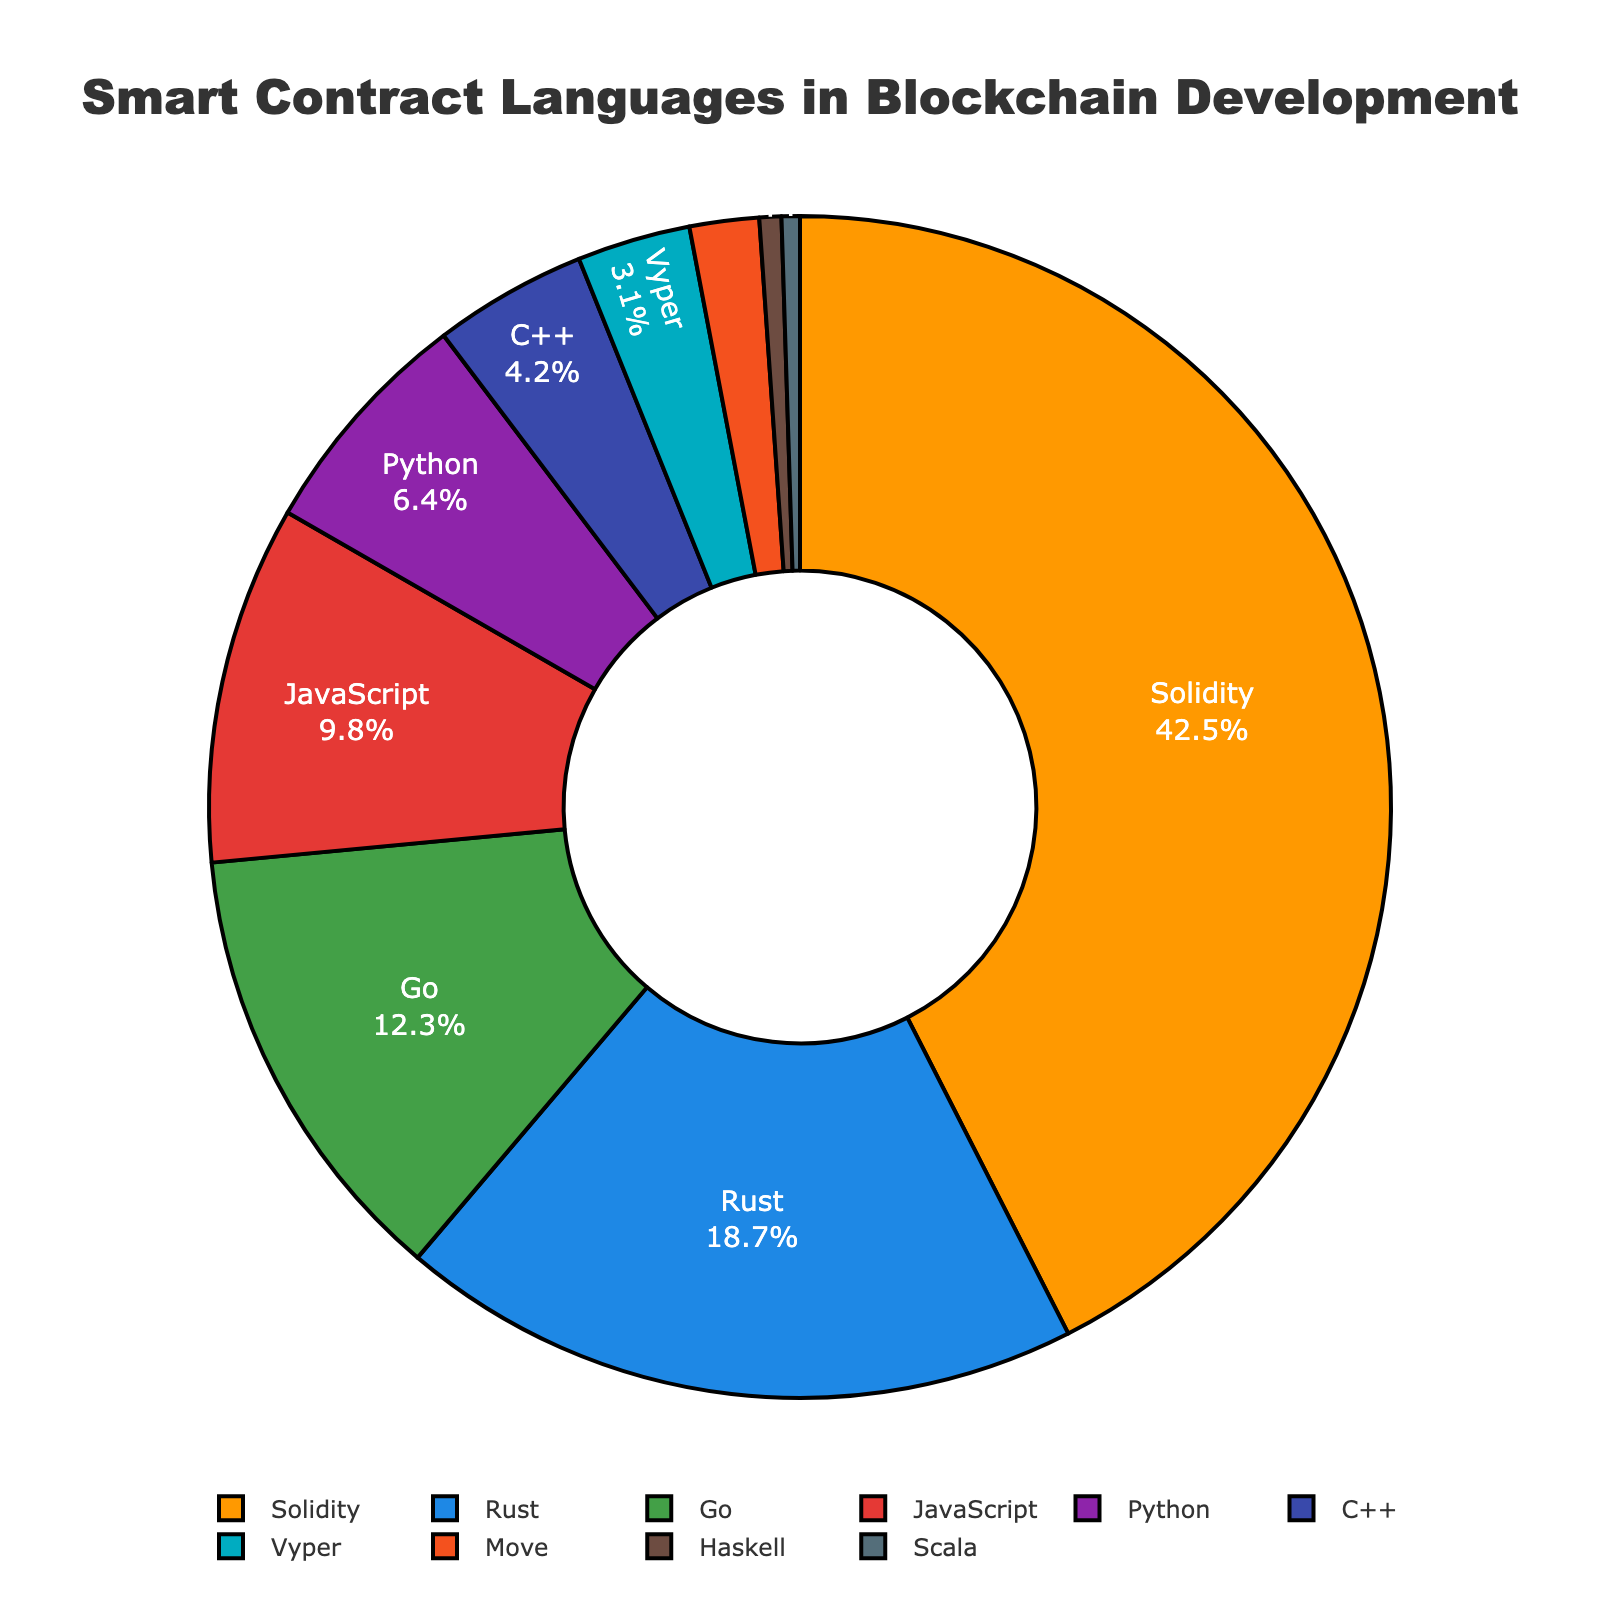Which smart contract language is the most commonly used in blockchain development? The largest segment of the pie chart, which represents 42.5%, is labeled as Solidity, indicating it is the most commonly used language.
Answer: Solidity How much more popular is Rust compared to Vyper in percentage points? The percentage for Rust is 18.7% and for Vyper is 3.1%. Subtracting the two values (18.7 - 3.1) gives us the difference.
Answer: 15.6% Are there any languages that have a usage percentage below 1%? By observing the pie chart, the languages represented by Haskell (0.6%) and Scala (0.5%) are both below 1%.
Answer: Yes What is the combined usage percentage of Go and Python? The percentage for Go is 12.3%, and for Python is 6.4%. Adding these two values gives us (12.3 + 6.4).
Answer: 18.7% Which language has the smallest representation in the chart, and what is its percentage? The smallest segment in the pie chart corresponds to Scala, which has a percentage of 0.5%.
Answer: Scala, 0.5% Which colors represent Rust and Go in the chart, and what are their respective percentages? Rust is represented by the second color (blue) and has a percentage of 18.7%; Go is represented by the third color (green) and has a percentage of 12.3%.
Answer: Rust (blue), 18.7% and Go (green), 12.3% How many languages have a usage percentage greater than or equal to 10%? By observing the pie chart, we see that Solidity (42.5%) and Rust (18.7%) are greater than 10%, and Go (12.3%) as well. This totals three languages.
Answer: Three Which languages have a usage percentage between 1% and 5%, inclusive? By examining the pie chart, we note that Vyper (3.1%), Move (1.9%), and C++ (4.2%) all fit within this range.
Answer: Vyper, Move, and C++ What is the average percentage usage of JavaScript and Python? The percentages for JavaScript and Python are 9.8% and 6.4%, respectively. The average is calculated as (9.8 + 6.4) / 2.
Answer: 8.1% How does the length of the segments for Solidity and JavaScript compare? Solidity's segment is significantly longer than JavaScript's, indicating Solidity's 42.5% usage is much higher than JavaScript's 9.8% usage.
Answer: Solidity's segment is much longer 